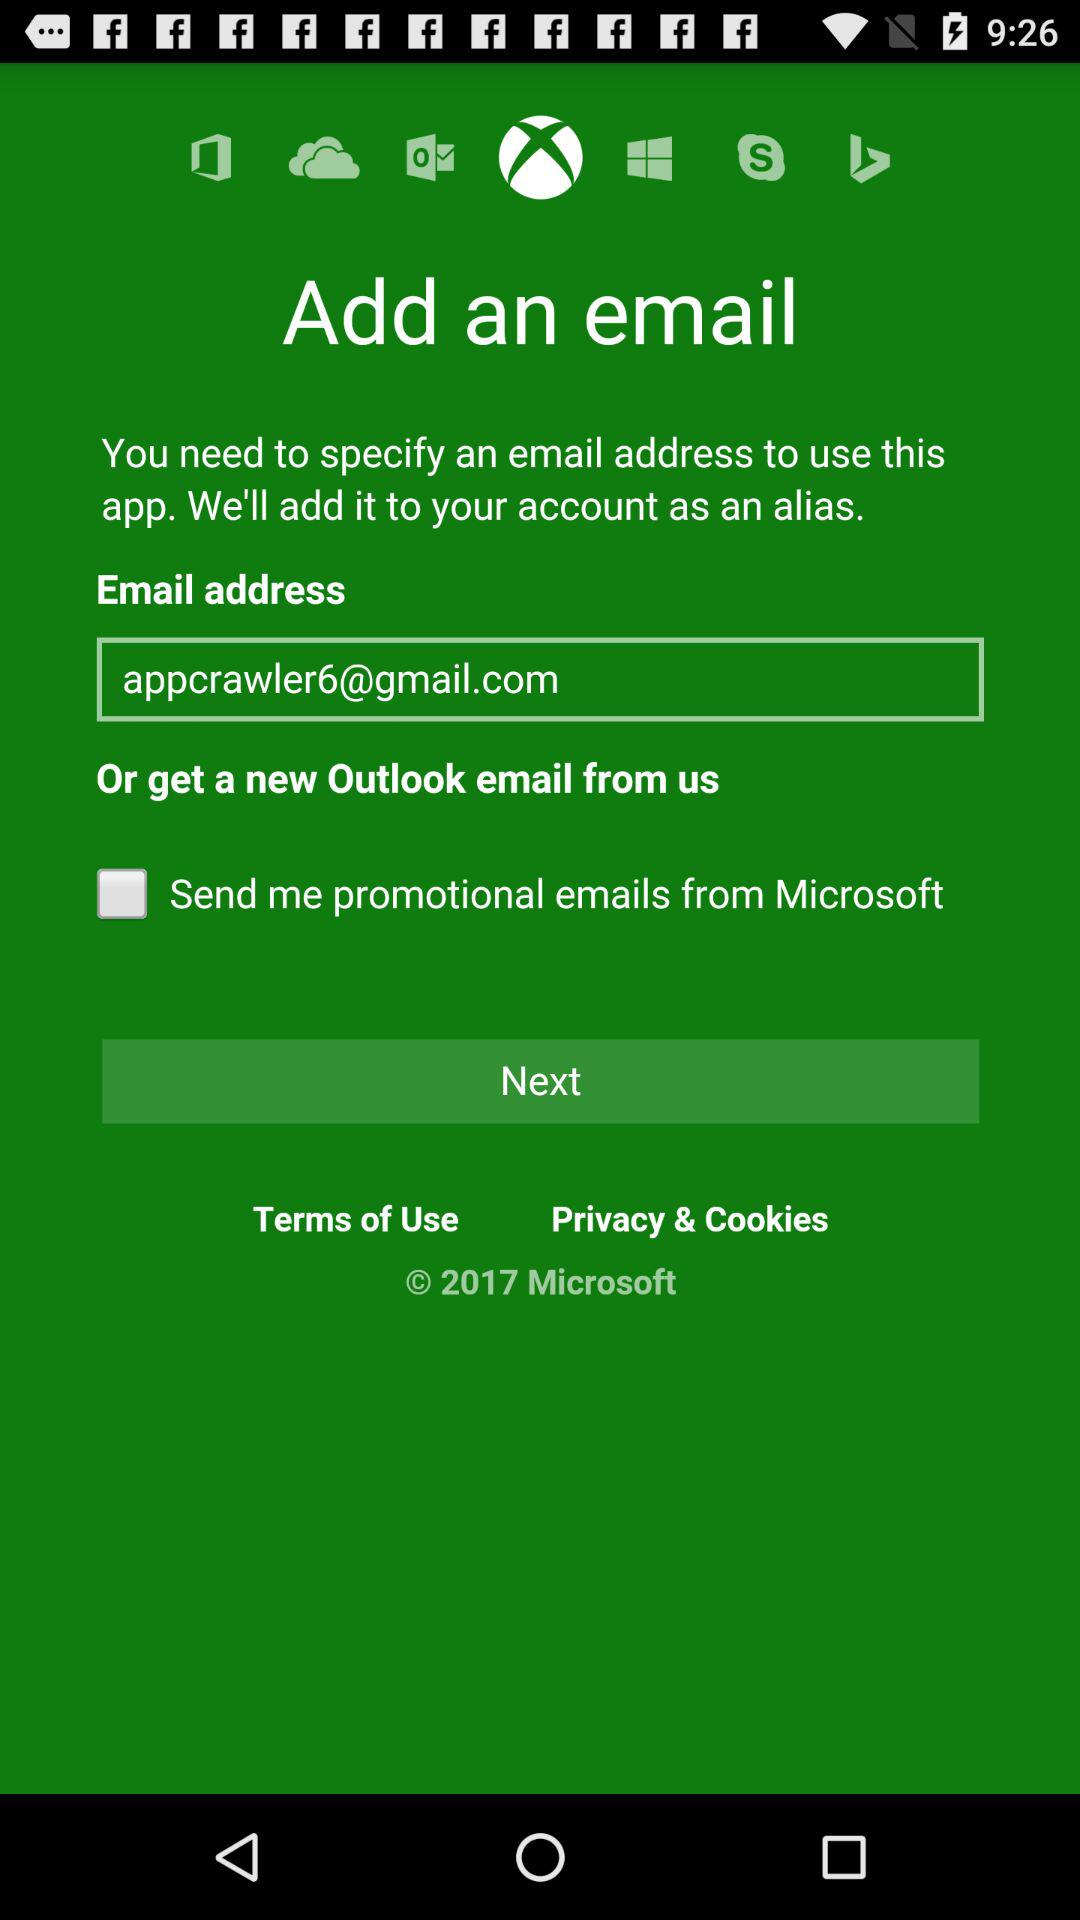How many options are there to add an email address?
Answer the question using a single word or phrase. 2 